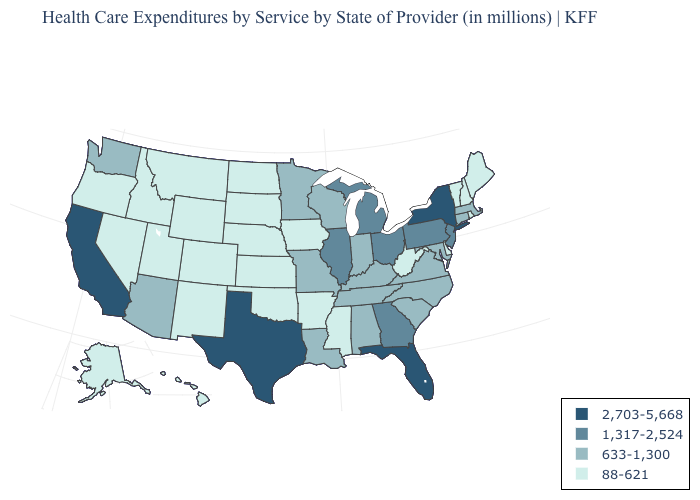Does Wyoming have the lowest value in the USA?
Concise answer only. Yes. What is the value of Michigan?
Be succinct. 1,317-2,524. Name the states that have a value in the range 1,317-2,524?
Concise answer only. Georgia, Illinois, Michigan, New Jersey, Ohio, Pennsylvania. Does Florida have the highest value in the USA?
Short answer required. Yes. Which states have the highest value in the USA?
Keep it brief. California, Florida, New York, Texas. Which states have the highest value in the USA?
Answer briefly. California, Florida, New York, Texas. How many symbols are there in the legend?
Keep it brief. 4. Does the map have missing data?
Write a very short answer. No. Does Nevada have a lower value than Minnesota?
Answer briefly. Yes. What is the value of Kansas?
Keep it brief. 88-621. Which states hav the highest value in the West?
Keep it brief. California. Name the states that have a value in the range 2,703-5,668?
Quick response, please. California, Florida, New York, Texas. Among the states that border Utah , does Arizona have the lowest value?
Give a very brief answer. No. Name the states that have a value in the range 633-1,300?
Concise answer only. Alabama, Arizona, Connecticut, Indiana, Kentucky, Louisiana, Maryland, Massachusetts, Minnesota, Missouri, North Carolina, South Carolina, Tennessee, Virginia, Washington, Wisconsin. Does Tennessee have the same value as Virginia?
Write a very short answer. Yes. 